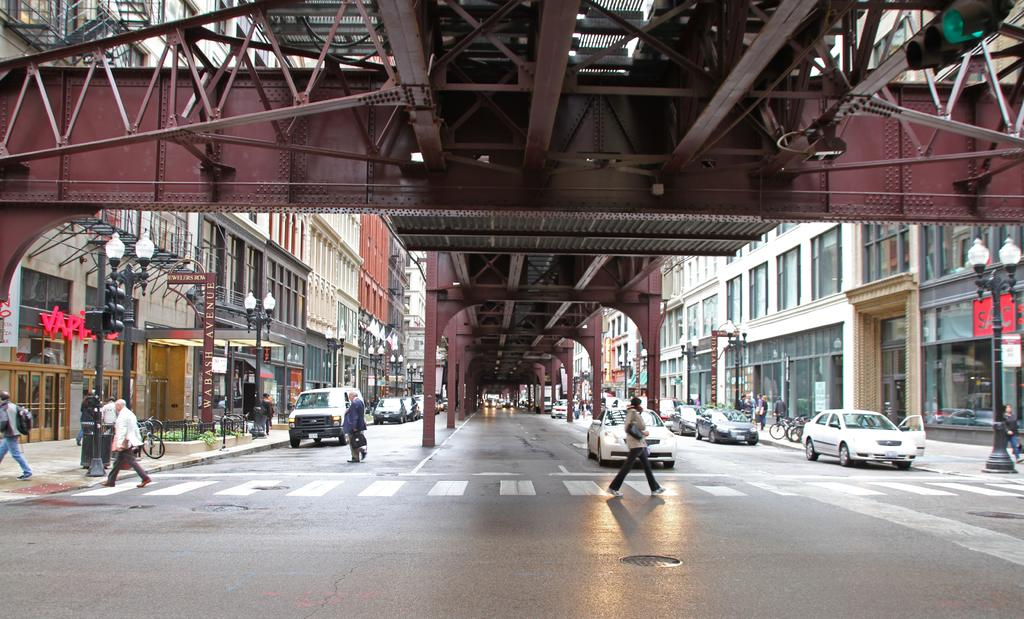<image>
Present a compact description of the photo's key features. a SAC sign outside of a building next to a bridge over a crosswalk 